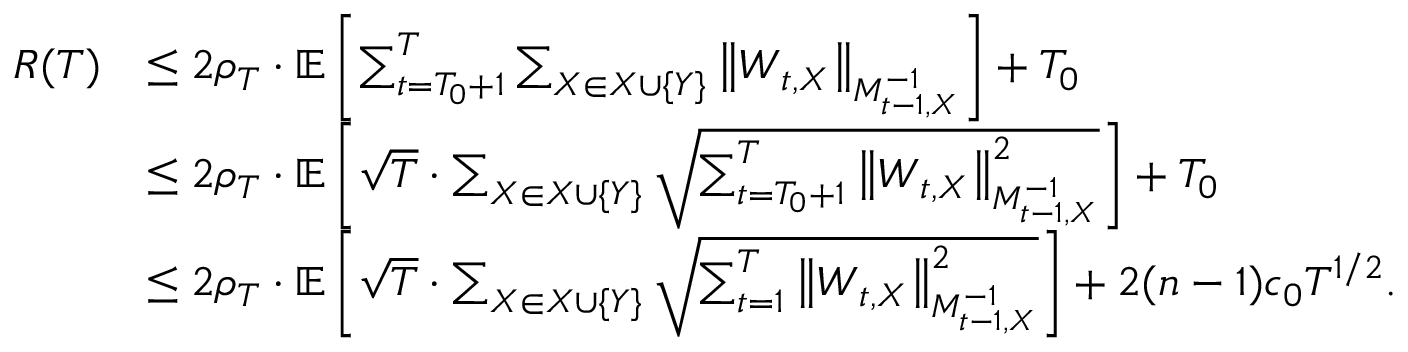Convert formula to latex. <formula><loc_0><loc_0><loc_500><loc_500>\begin{array} { r l } { R ( T ) } & { \leq 2 \rho _ { T } \cdot \mathbb { E } \left [ \sum _ { t = T _ { 0 } + 1 } ^ { T } \sum _ { X \in X \cup \{ Y \} } \left \| W _ { t , X } \right \| _ { M _ { t - 1 , X } ^ { - 1 } } \right ] + T _ { 0 } } \\ & { \leq 2 \rho _ { T } \cdot \mathbb { E } \left [ \sqrt { T } \cdot \sum _ { X \in X \cup \{ Y \} } \sqrt { \sum _ { t = T _ { 0 } + 1 } ^ { T } \left \| W _ { t , X } \right \| _ { M _ { t - 1 , X } ^ { - 1 } } ^ { 2 } } \right ] + T _ { 0 } } \\ & { \leq 2 \rho _ { T } \cdot \mathbb { E } \left [ \sqrt { T } \cdot \sum _ { X \in X \cup \{ Y \} } \sqrt { \sum _ { t = 1 } ^ { T } \left \| W _ { t , X } \right \| _ { M _ { t - 1 , X } ^ { - 1 } } ^ { 2 } } \right ] + 2 ( n - 1 ) c _ { 0 } T ^ { 1 / 2 } . } \end{array}</formula> 